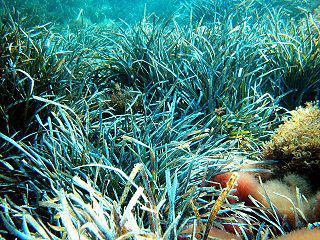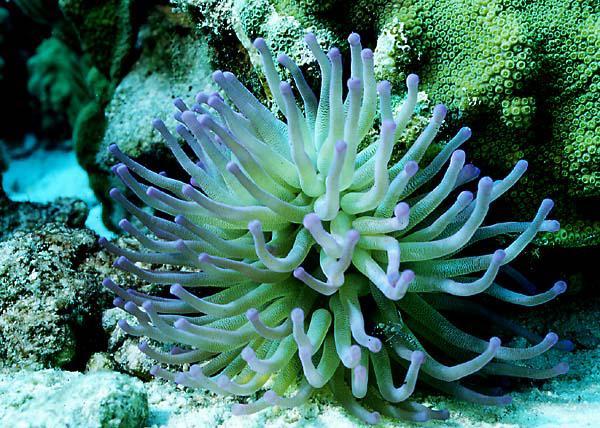The first image is the image on the left, the second image is the image on the right. For the images shown, is this caption "Both images contain only sea anemones and rocks." true? Answer yes or no. No. The first image is the image on the left, the second image is the image on the right. Given the left and right images, does the statement "The colors of the anemones are soft greens and blues." hold true? Answer yes or no. Yes. 